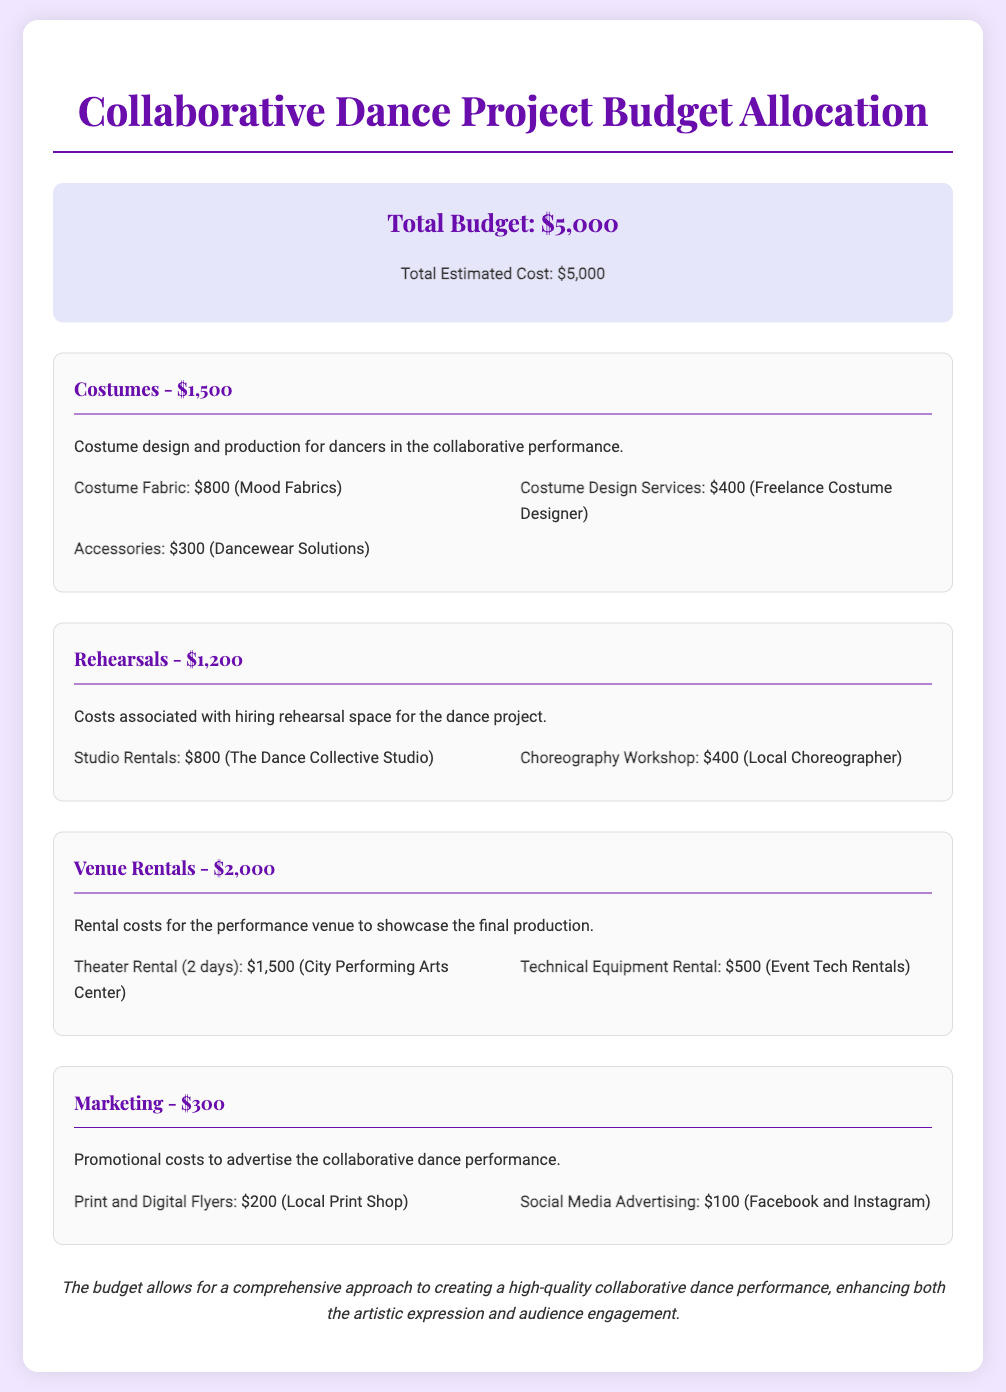What is the total budget? The total budget is clearly stated at the top of the document as $5,000.
Answer: $5,000 How much is allocated for costumes? The allocation for costumes is detailed in the budget and amounts to $1,500.
Answer: $1,500 What is the cost of studio rentals? The cost of studio rentals is specifically mentioned as $800 within the rehearsal section.
Answer: $800 How much will be spent on marketing? The marketing expenses are listed as $300 in the budget overview.
Answer: $300 What venue rental cost is mentioned for theater rental? The theater rental cost for two days is explicitly noted to be $1,500.
Answer: $1,500 What percentage of the total budget is allocated to rehearsals? Rehearsals cost $1,200, which is calculated as a percentage of the total budget of $5,000 (24%).
Answer: 24% Which company is providing costume design services? The document states that a freelance costume designer is providing the costume design services at a cost of $400.
Answer: Freelance Costume Designer What are the total costs associated with accessories? The total costs for accessories is specified as $300 in the costumes allocation.
Answer: $300 What is the cost for social media advertising? The document specifies that the cost for social media advertising is $100.
Answer: $100 